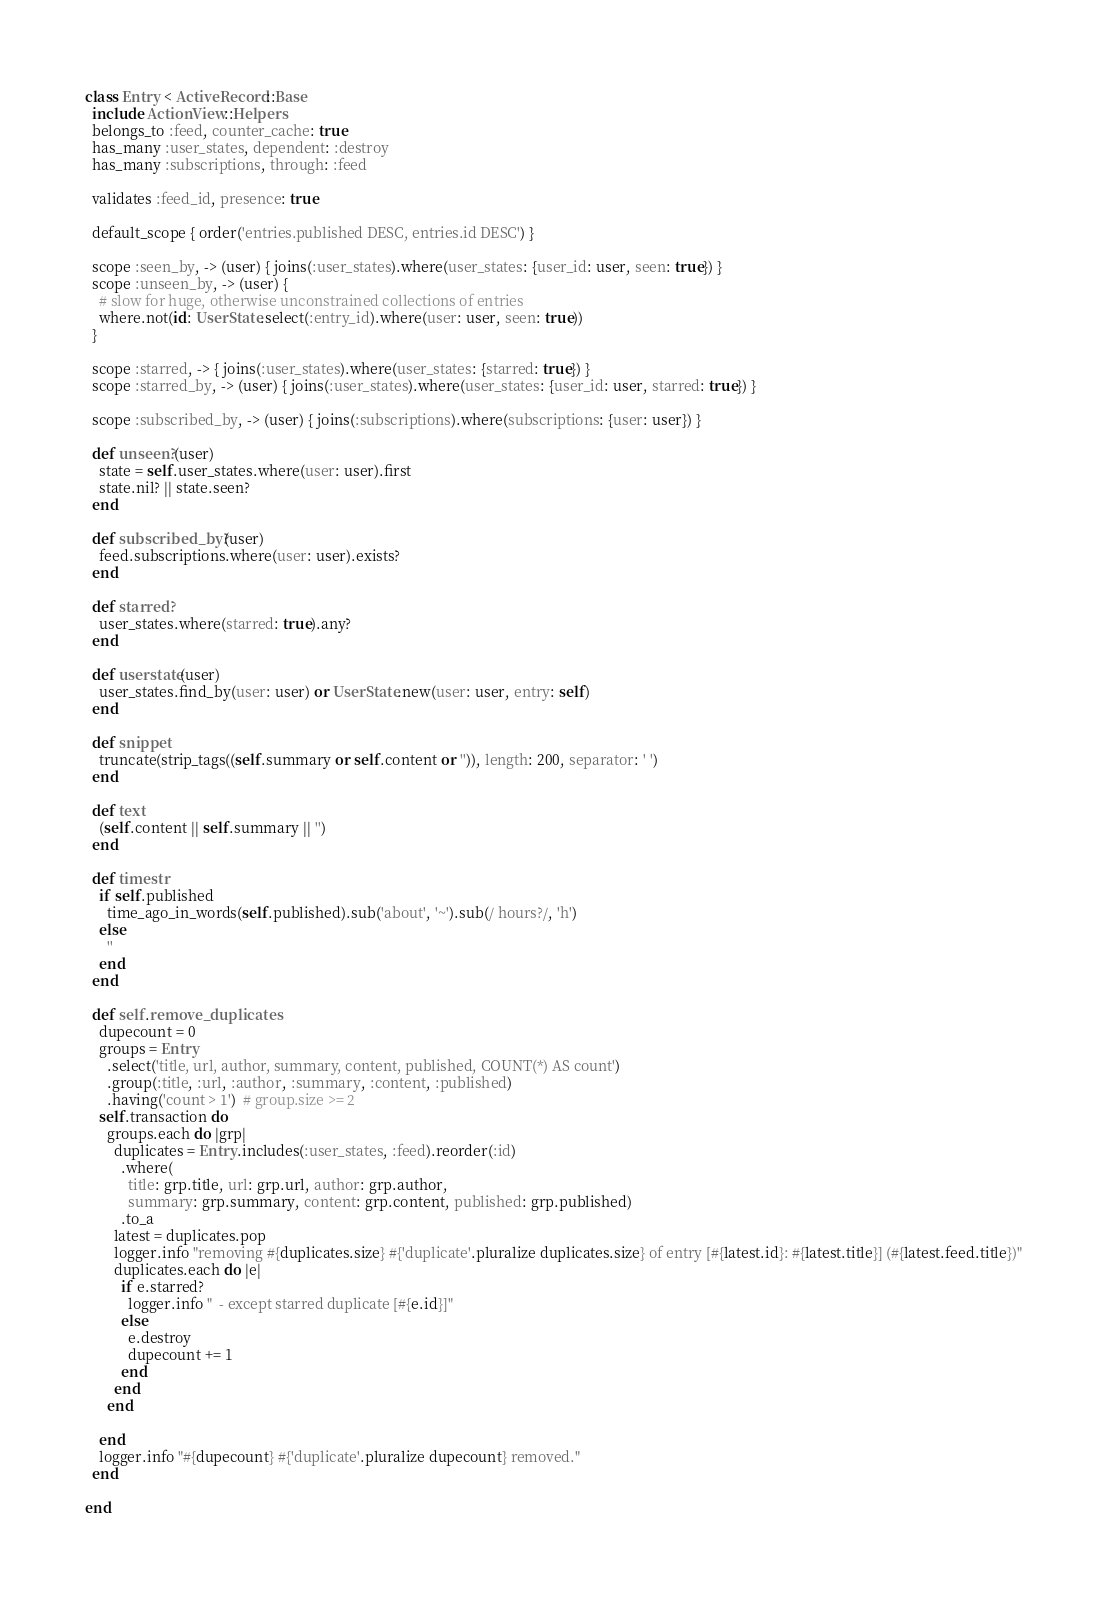Convert code to text. <code><loc_0><loc_0><loc_500><loc_500><_Ruby_>class Entry < ActiveRecord::Base
  include ActionView::Helpers
  belongs_to :feed, counter_cache: true
  has_many :user_states, dependent: :destroy
  has_many :subscriptions, through: :feed

  validates :feed_id, presence: true

  default_scope { order('entries.published DESC, entries.id DESC') }

  scope :seen_by, -> (user) { joins(:user_states).where(user_states: {user_id: user, seen: true}) }
  scope :unseen_by, -> (user) {
    # slow for huge, otherwise unconstrained collections of entries
    where.not(id: UserState.select(:entry_id).where(user: user, seen: true))
  }

  scope :starred, -> { joins(:user_states).where(user_states: {starred: true}) }
  scope :starred_by, -> (user) { joins(:user_states).where(user_states: {user_id: user, starred: true}) }

  scope :subscribed_by, -> (user) { joins(:subscriptions).where(subscriptions: {user: user}) }

  def unseen?(user)
    state = self.user_states.where(user: user).first
    state.nil? || state.seen?
  end

  def subscribed_by?(user)
    feed.subscriptions.where(user: user).exists?
  end

  def starred?
    user_states.where(starred: true).any?
  end

  def userstate(user)
    user_states.find_by(user: user) or UserState.new(user: user, entry: self)
  end

  def snippet
    truncate(strip_tags((self.summary or self.content or '')), length: 200, separator: ' ')
  end

  def text
    (self.content || self.summary || '')
  end

  def timestr
    if self.published
      time_ago_in_words(self.published).sub('about', '~').sub(/ hours?/, 'h')
    else
      ''
    end
  end

  def self.remove_duplicates
    dupecount = 0
    groups = Entry
      .select('title, url, author, summary, content, published, COUNT(*) AS count')
      .group(:title, :url, :author, :summary, :content, :published)
      .having('count > 1')  # group.size >= 2
    self.transaction do
      groups.each do |grp|
        duplicates = Entry.includes(:user_states, :feed).reorder(:id)
          .where(
            title: grp.title, url: grp.url, author: grp.author,
            summary: grp.summary, content: grp.content, published: grp.published)
          .to_a
        latest = duplicates.pop
        logger.info "removing #{duplicates.size} #{'duplicate'.pluralize duplicates.size} of entry [#{latest.id}: #{latest.title}] (#{latest.feed.title})"
        duplicates.each do |e|
          if e.starred?
            logger.info "  - except starred duplicate [#{e.id}]"
          else
            e.destroy
            dupecount += 1
          end
        end
      end

    end
    logger.info "#{dupecount} #{'duplicate'.pluralize dupecount} removed."
  end

end
</code> 